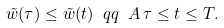<formula> <loc_0><loc_0><loc_500><loc_500>\tilde { w } ( \tau ) \leq \tilde { w } ( t ) \ q q \ A \, \tau \leq t \leq T .</formula> 